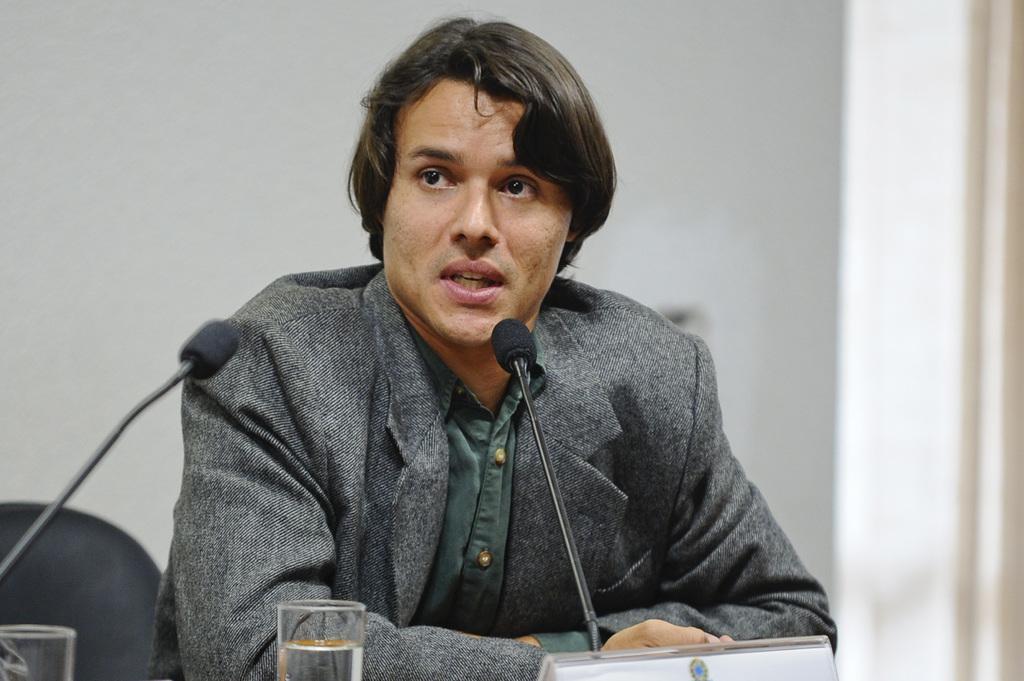Can you describe this image briefly? In this image we can see a man, makes, glasses and a chair. 